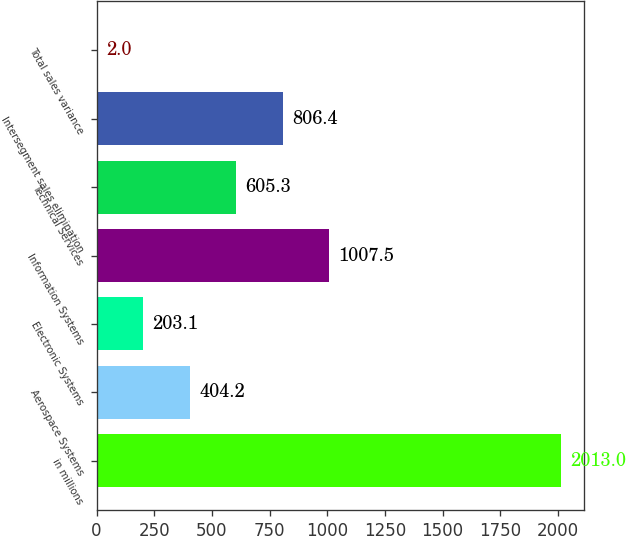Convert chart. <chart><loc_0><loc_0><loc_500><loc_500><bar_chart><fcel>in millions<fcel>Aerospace Systems<fcel>Electronic Systems<fcel>Information Systems<fcel>Technical Services<fcel>Intersegment sales elimination<fcel>Total sales variance<nl><fcel>2013<fcel>404.2<fcel>203.1<fcel>1007.5<fcel>605.3<fcel>806.4<fcel>2<nl></chart> 